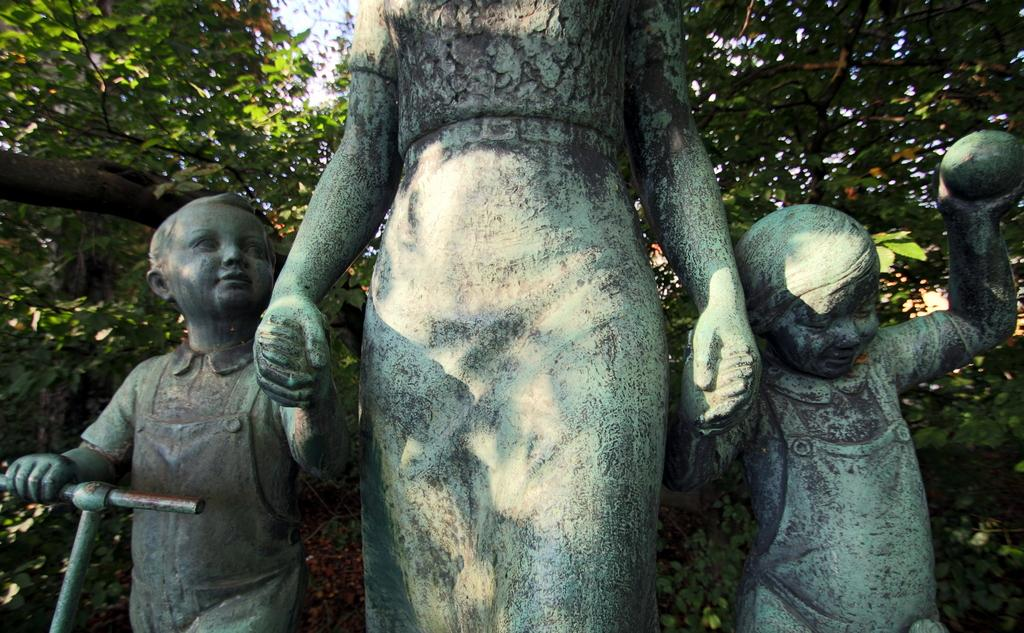What is depicted in the image? There are statues of three people in the image. What can be seen in the background of the image? There are trees visible in the background of the image. What is visible at the top of the image? The sky is visible at the top of the image. What type of needle is being used by the person in the image? There is no needle present in the image; it features statues of three people. What is the person in the image doing with their head? The image features statues, which are not capable of performing actions like using a needle or doing anything with their heads. 